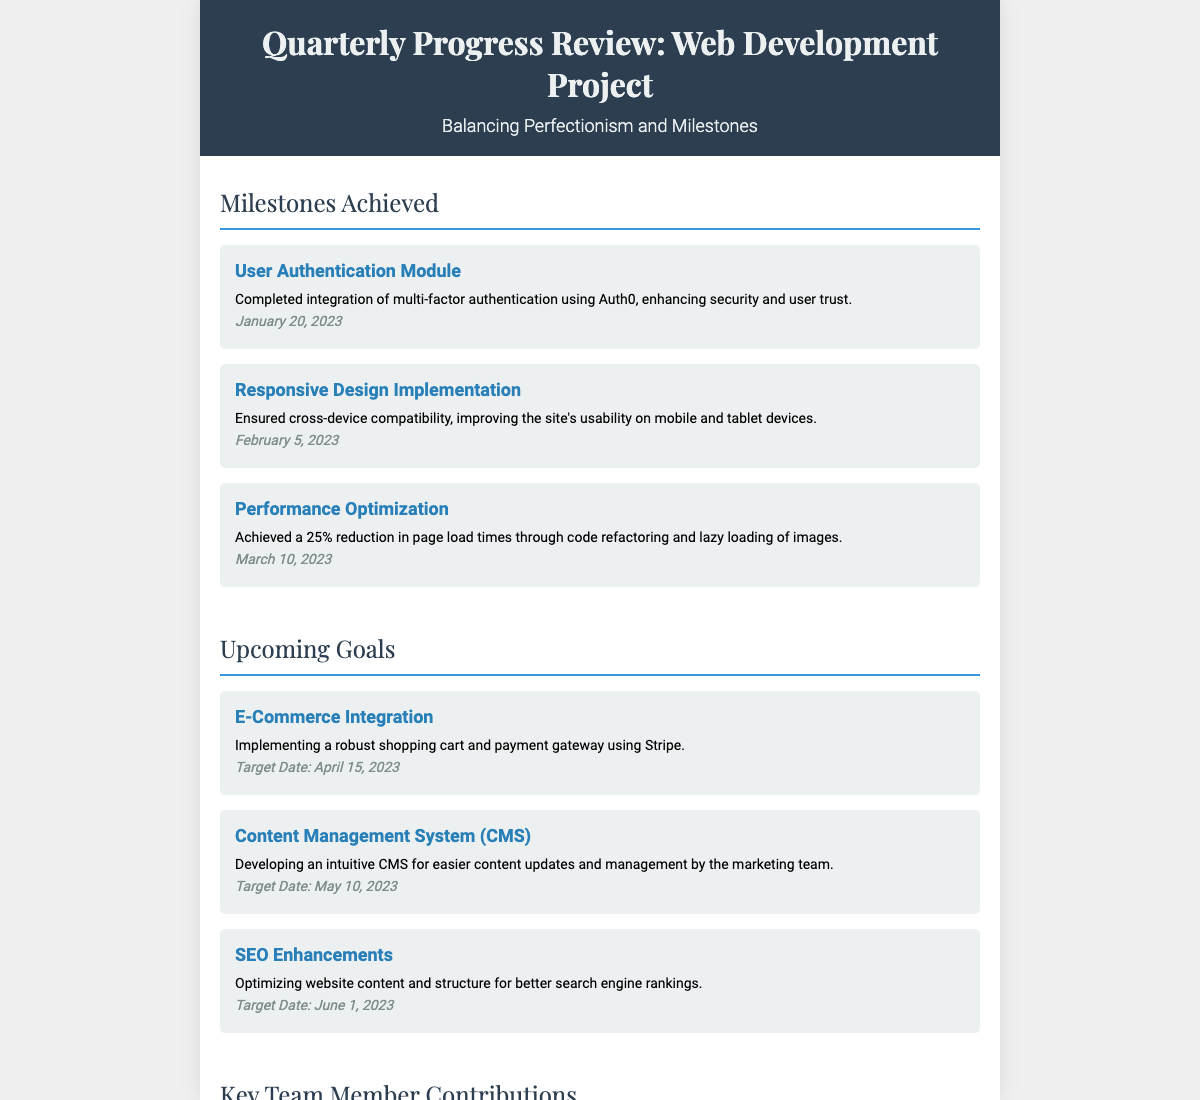What is the title of the project review? The title of the project review is presented in the header of the document.
Answer: Quarterly Progress Review: Web Development Project Who is responsible for the E-Commerce Integration? The upcoming goal of integrating E-commerce is specified in the upcoming goals section without attributing it to a specific team member.
Answer: Not specified What is the target date for SEO Enhancements? The target date for SEO enhancements is clearly indicated in the upcoming goals section.
Answer: June 1, 2023 Which team member led the responsive design overhaul? The section about key team member contributions specifies Emily Johnson's role in the responsive design overhaul.
Answer: Emily Johnson What percentage reduction in page load times was achieved through performance optimization? The document states the achieved reduction in page load times under the milestones achieved.
Answer: 25% What is the focus of the User Authentication Module milestone? The document elaborates on the key features of the User Authentication Module within the milestones achieved.
Answer: Multi-factor authentication How did Sophia Martinez contribute to the project? The key team member contributions section details Sophia's role in coordinating teams to meet milestones.
Answer: Coordinated between various teams What date was the Responsive Design Implementation milestone completed? The completion date for the Responsive Design Implementation is noted in the milestones achieved section.
Answer: February 5, 2023 What was achieved on January 20, 2023? The date is linked to the completion of the User Authentication Module milestone in the document.
Answer: User Authentication Module 